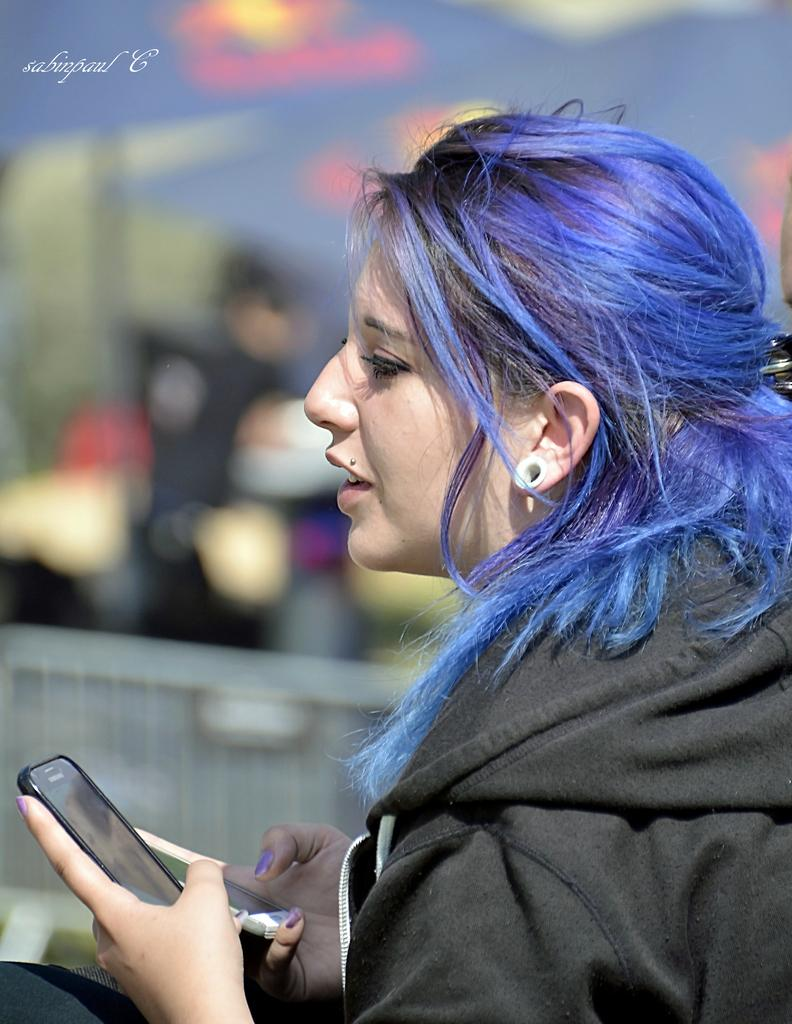Who is the main subject in the picture? There is a woman in the picture. What is the woman wearing? The woman is wearing a black jacket. What is unique about the woman's appearance? The woman has blue hair. What expression does the woman have? The woman is smiling. What object is the woman holding in her hand? The woman is holding a phone in her hand. What can be seen in the background of the image? The sky is visible in the image. What type of pie is the woman eating in the image? There is no pie present in the image; the woman is holding a phone. What fictional character does the woman resemble in the image? There is no reference to any fictional character in the image; the woman has blue hair and is wearing a black jacket. 